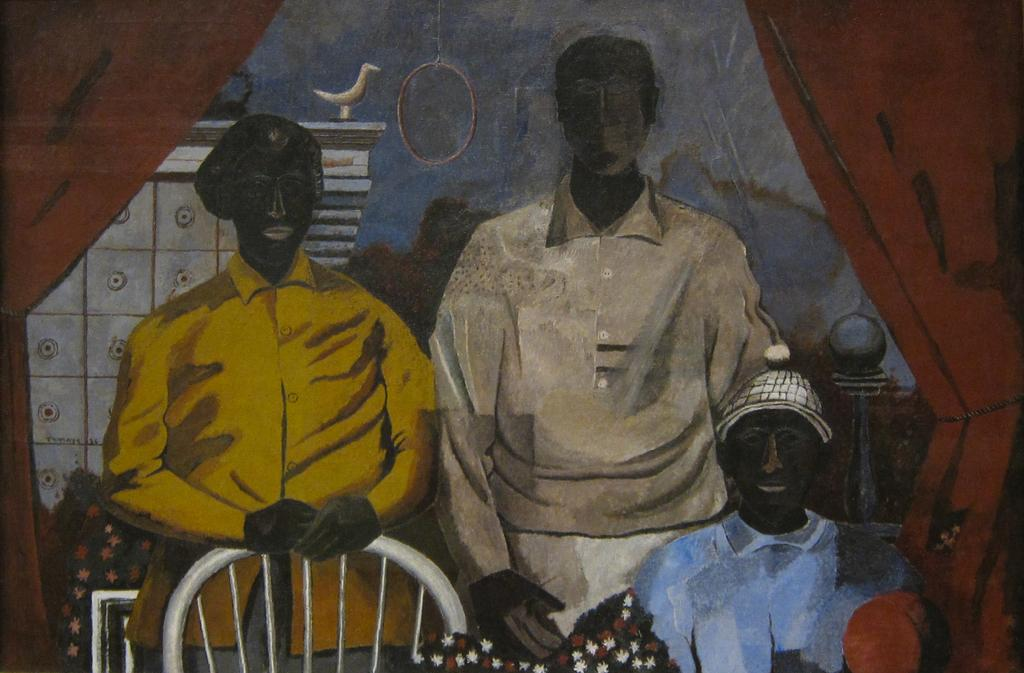What is the main subject of the image? The image contains a painting. What is depicted in the painting? The painting depicts three persons. Are there any objects in the painting besides the persons? Yes, there is a chair in the painting. What can be seen in the background of the painting? There is a bird and other objects in the background of the painting. What color are the curtains in the background of the painting? The curtains in the background of the painting are brown. What type of meat is being served in the painting? There is no meat present in the painting; it depicts three persons, a chair, and objects in the background. What song is being sung by the persons in the painting? There is no indication of any song being sung in the painting; it only depicts visual elements. 